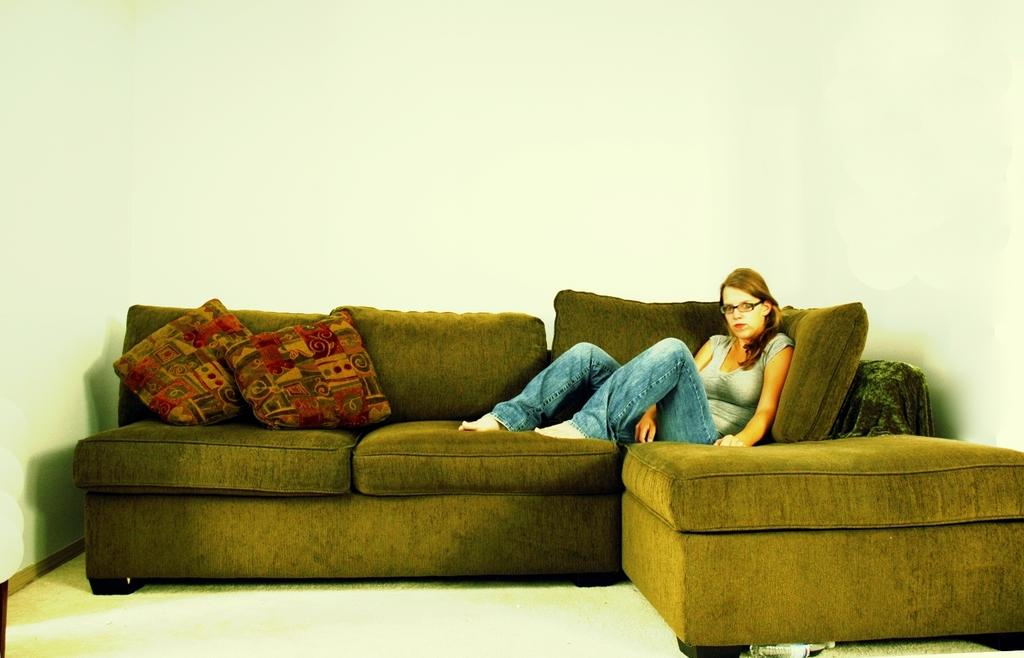Who is present in the image? There is a woman in the image. What is the woman doing in the image? The woman is sitting on a sofa. Can you describe the sofa in the image? The sofa has two pillows on it. What color is the background wall in the image? The background wall is white in color. What type of rail can be seen in the image? There is no rail present in the image. What kind of work is the woman doing in the image? The image does not show the woman working or performing any specific task. 